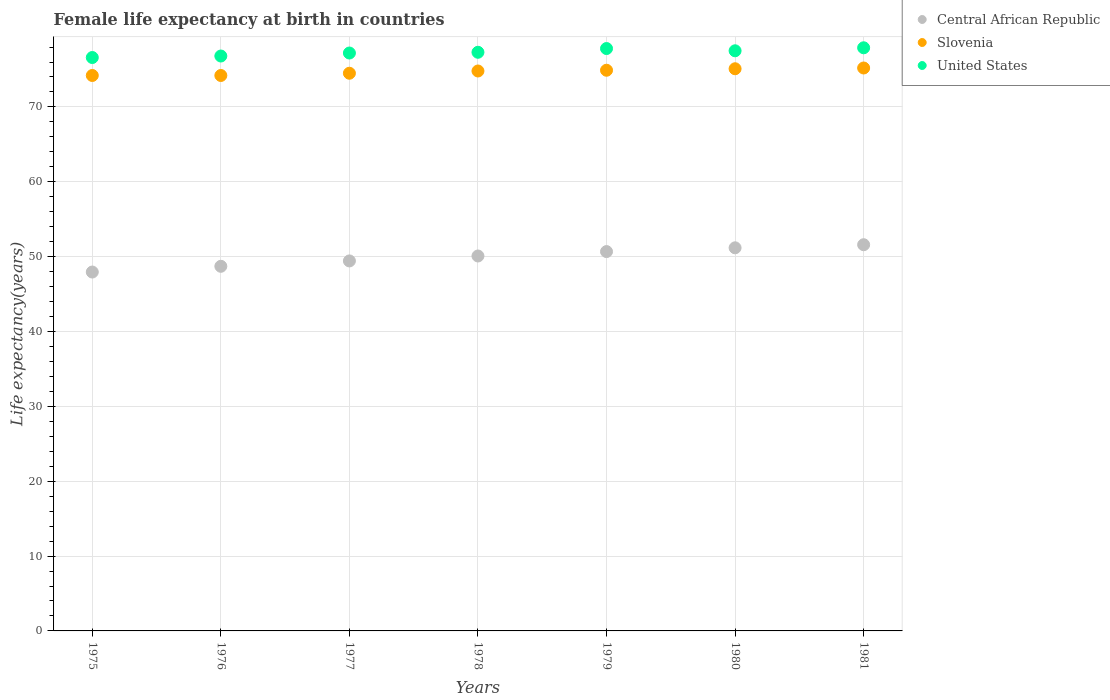What is the female life expectancy at birth in Central African Republic in 1977?
Your response must be concise. 49.43. Across all years, what is the maximum female life expectancy at birth in Central African Republic?
Provide a succinct answer. 51.59. Across all years, what is the minimum female life expectancy at birth in Central African Republic?
Your answer should be very brief. 47.94. In which year was the female life expectancy at birth in Central African Republic maximum?
Provide a short and direct response. 1981. In which year was the female life expectancy at birth in Central African Republic minimum?
Offer a very short reply. 1975. What is the total female life expectancy at birth in Slovenia in the graph?
Give a very brief answer. 522.9. What is the difference between the female life expectancy at birth in Slovenia in 1975 and that in 1976?
Ensure brevity in your answer.  0. What is the difference between the female life expectancy at birth in United States in 1981 and the female life expectancy at birth in Central African Republic in 1976?
Provide a short and direct response. 29.19. What is the average female life expectancy at birth in Slovenia per year?
Keep it short and to the point. 74.7. In the year 1977, what is the difference between the female life expectancy at birth in Slovenia and female life expectancy at birth in Central African Republic?
Give a very brief answer. 25.07. What is the ratio of the female life expectancy at birth in Slovenia in 1976 to that in 1981?
Make the answer very short. 0.99. Is the female life expectancy at birth in United States in 1976 less than that in 1980?
Keep it short and to the point. Yes. What is the difference between the highest and the second highest female life expectancy at birth in Central African Republic?
Provide a short and direct response. 0.41. What is the difference between the highest and the lowest female life expectancy at birth in United States?
Offer a very short reply. 1.3. Is the sum of the female life expectancy at birth in Slovenia in 1977 and 1979 greater than the maximum female life expectancy at birth in Central African Republic across all years?
Give a very brief answer. Yes. Does the female life expectancy at birth in United States monotonically increase over the years?
Offer a terse response. No. Is the female life expectancy at birth in United States strictly less than the female life expectancy at birth in Slovenia over the years?
Offer a very short reply. No. How many dotlines are there?
Your response must be concise. 3. How many years are there in the graph?
Provide a succinct answer. 7. Are the values on the major ticks of Y-axis written in scientific E-notation?
Give a very brief answer. No. Does the graph contain grids?
Give a very brief answer. Yes. Where does the legend appear in the graph?
Offer a very short reply. Top right. What is the title of the graph?
Offer a terse response. Female life expectancy at birth in countries. What is the label or title of the X-axis?
Ensure brevity in your answer.  Years. What is the label or title of the Y-axis?
Keep it short and to the point. Life expectancy(years). What is the Life expectancy(years) in Central African Republic in 1975?
Offer a terse response. 47.94. What is the Life expectancy(years) in Slovenia in 1975?
Provide a short and direct response. 74.2. What is the Life expectancy(years) in United States in 1975?
Your answer should be very brief. 76.6. What is the Life expectancy(years) in Central African Republic in 1976?
Your response must be concise. 48.71. What is the Life expectancy(years) in Slovenia in 1976?
Keep it short and to the point. 74.2. What is the Life expectancy(years) in United States in 1976?
Offer a terse response. 76.8. What is the Life expectancy(years) of Central African Republic in 1977?
Make the answer very short. 49.43. What is the Life expectancy(years) of Slovenia in 1977?
Your answer should be very brief. 74.5. What is the Life expectancy(years) of United States in 1977?
Keep it short and to the point. 77.2. What is the Life expectancy(years) of Central African Republic in 1978?
Offer a very short reply. 50.09. What is the Life expectancy(years) in Slovenia in 1978?
Your response must be concise. 74.8. What is the Life expectancy(years) in United States in 1978?
Offer a very short reply. 77.3. What is the Life expectancy(years) of Central African Republic in 1979?
Offer a terse response. 50.67. What is the Life expectancy(years) in Slovenia in 1979?
Offer a terse response. 74.9. What is the Life expectancy(years) in United States in 1979?
Give a very brief answer. 77.8. What is the Life expectancy(years) of Central African Republic in 1980?
Keep it short and to the point. 51.18. What is the Life expectancy(years) of Slovenia in 1980?
Keep it short and to the point. 75.1. What is the Life expectancy(years) of United States in 1980?
Ensure brevity in your answer.  77.5. What is the Life expectancy(years) in Central African Republic in 1981?
Give a very brief answer. 51.59. What is the Life expectancy(years) of Slovenia in 1981?
Offer a terse response. 75.2. What is the Life expectancy(years) of United States in 1981?
Your answer should be compact. 77.9. Across all years, what is the maximum Life expectancy(years) in Central African Republic?
Give a very brief answer. 51.59. Across all years, what is the maximum Life expectancy(years) of Slovenia?
Offer a terse response. 75.2. Across all years, what is the maximum Life expectancy(years) of United States?
Ensure brevity in your answer.  77.9. Across all years, what is the minimum Life expectancy(years) in Central African Republic?
Your answer should be compact. 47.94. Across all years, what is the minimum Life expectancy(years) of Slovenia?
Offer a very short reply. 74.2. Across all years, what is the minimum Life expectancy(years) in United States?
Provide a succinct answer. 76.6. What is the total Life expectancy(years) of Central African Republic in the graph?
Your answer should be compact. 349.61. What is the total Life expectancy(years) in Slovenia in the graph?
Your response must be concise. 522.9. What is the total Life expectancy(years) in United States in the graph?
Provide a short and direct response. 541.1. What is the difference between the Life expectancy(years) of Central African Republic in 1975 and that in 1976?
Your answer should be compact. -0.77. What is the difference between the Life expectancy(years) in United States in 1975 and that in 1976?
Keep it short and to the point. -0.2. What is the difference between the Life expectancy(years) in Central African Republic in 1975 and that in 1977?
Give a very brief answer. -1.48. What is the difference between the Life expectancy(years) in Slovenia in 1975 and that in 1977?
Provide a succinct answer. -0.3. What is the difference between the Life expectancy(years) in Central African Republic in 1975 and that in 1978?
Offer a terse response. -2.14. What is the difference between the Life expectancy(years) in Central African Republic in 1975 and that in 1979?
Your answer should be very brief. -2.73. What is the difference between the Life expectancy(years) in Slovenia in 1975 and that in 1979?
Provide a short and direct response. -0.7. What is the difference between the Life expectancy(years) of Central African Republic in 1975 and that in 1980?
Your answer should be compact. -3.24. What is the difference between the Life expectancy(years) of United States in 1975 and that in 1980?
Give a very brief answer. -0.9. What is the difference between the Life expectancy(years) of Central African Republic in 1975 and that in 1981?
Offer a very short reply. -3.65. What is the difference between the Life expectancy(years) in Slovenia in 1975 and that in 1981?
Your answer should be compact. -1. What is the difference between the Life expectancy(years) of Central African Republic in 1976 and that in 1977?
Your answer should be very brief. -0.72. What is the difference between the Life expectancy(years) of Central African Republic in 1976 and that in 1978?
Ensure brevity in your answer.  -1.38. What is the difference between the Life expectancy(years) in Slovenia in 1976 and that in 1978?
Ensure brevity in your answer.  -0.6. What is the difference between the Life expectancy(years) of Central African Republic in 1976 and that in 1979?
Your answer should be compact. -1.97. What is the difference between the Life expectancy(years) of Slovenia in 1976 and that in 1979?
Provide a short and direct response. -0.7. What is the difference between the Life expectancy(years) in Central African Republic in 1976 and that in 1980?
Your answer should be very brief. -2.47. What is the difference between the Life expectancy(years) in United States in 1976 and that in 1980?
Keep it short and to the point. -0.7. What is the difference between the Life expectancy(years) of Central African Republic in 1976 and that in 1981?
Your answer should be very brief. -2.88. What is the difference between the Life expectancy(years) in Slovenia in 1976 and that in 1981?
Make the answer very short. -1. What is the difference between the Life expectancy(years) of Central African Republic in 1977 and that in 1978?
Your answer should be very brief. -0.66. What is the difference between the Life expectancy(years) of Slovenia in 1977 and that in 1978?
Give a very brief answer. -0.3. What is the difference between the Life expectancy(years) of United States in 1977 and that in 1978?
Offer a very short reply. -0.1. What is the difference between the Life expectancy(years) of Central African Republic in 1977 and that in 1979?
Offer a terse response. -1.25. What is the difference between the Life expectancy(years) in Central African Republic in 1977 and that in 1980?
Offer a very short reply. -1.75. What is the difference between the Life expectancy(years) in Slovenia in 1977 and that in 1980?
Make the answer very short. -0.6. What is the difference between the Life expectancy(years) of Central African Republic in 1977 and that in 1981?
Ensure brevity in your answer.  -2.17. What is the difference between the Life expectancy(years) of Central African Republic in 1978 and that in 1979?
Provide a succinct answer. -0.59. What is the difference between the Life expectancy(years) of Slovenia in 1978 and that in 1979?
Offer a very short reply. -0.1. What is the difference between the Life expectancy(years) of Central African Republic in 1978 and that in 1980?
Keep it short and to the point. -1.09. What is the difference between the Life expectancy(years) in Central African Republic in 1978 and that in 1981?
Your response must be concise. -1.5. What is the difference between the Life expectancy(years) of Central African Republic in 1979 and that in 1980?
Give a very brief answer. -0.5. What is the difference between the Life expectancy(years) of Slovenia in 1979 and that in 1980?
Your response must be concise. -0.2. What is the difference between the Life expectancy(years) of United States in 1979 and that in 1980?
Provide a short and direct response. 0.3. What is the difference between the Life expectancy(years) of Central African Republic in 1979 and that in 1981?
Keep it short and to the point. -0.92. What is the difference between the Life expectancy(years) of Central African Republic in 1980 and that in 1981?
Provide a short and direct response. -0.41. What is the difference between the Life expectancy(years) of Slovenia in 1980 and that in 1981?
Ensure brevity in your answer.  -0.1. What is the difference between the Life expectancy(years) of Central African Republic in 1975 and the Life expectancy(years) of Slovenia in 1976?
Ensure brevity in your answer.  -26.26. What is the difference between the Life expectancy(years) of Central African Republic in 1975 and the Life expectancy(years) of United States in 1976?
Offer a terse response. -28.86. What is the difference between the Life expectancy(years) of Slovenia in 1975 and the Life expectancy(years) of United States in 1976?
Offer a very short reply. -2.6. What is the difference between the Life expectancy(years) of Central African Republic in 1975 and the Life expectancy(years) of Slovenia in 1977?
Keep it short and to the point. -26.56. What is the difference between the Life expectancy(years) of Central African Republic in 1975 and the Life expectancy(years) of United States in 1977?
Your answer should be compact. -29.26. What is the difference between the Life expectancy(years) of Central African Republic in 1975 and the Life expectancy(years) of Slovenia in 1978?
Give a very brief answer. -26.86. What is the difference between the Life expectancy(years) in Central African Republic in 1975 and the Life expectancy(years) in United States in 1978?
Provide a succinct answer. -29.36. What is the difference between the Life expectancy(years) in Slovenia in 1975 and the Life expectancy(years) in United States in 1978?
Provide a succinct answer. -3.1. What is the difference between the Life expectancy(years) in Central African Republic in 1975 and the Life expectancy(years) in Slovenia in 1979?
Offer a terse response. -26.96. What is the difference between the Life expectancy(years) of Central African Republic in 1975 and the Life expectancy(years) of United States in 1979?
Make the answer very short. -29.86. What is the difference between the Life expectancy(years) of Central African Republic in 1975 and the Life expectancy(years) of Slovenia in 1980?
Ensure brevity in your answer.  -27.16. What is the difference between the Life expectancy(years) in Central African Republic in 1975 and the Life expectancy(years) in United States in 1980?
Your answer should be compact. -29.56. What is the difference between the Life expectancy(years) in Central African Republic in 1975 and the Life expectancy(years) in Slovenia in 1981?
Make the answer very short. -27.26. What is the difference between the Life expectancy(years) in Central African Republic in 1975 and the Life expectancy(years) in United States in 1981?
Give a very brief answer. -29.96. What is the difference between the Life expectancy(years) in Slovenia in 1975 and the Life expectancy(years) in United States in 1981?
Offer a very short reply. -3.7. What is the difference between the Life expectancy(years) of Central African Republic in 1976 and the Life expectancy(years) of Slovenia in 1977?
Offer a terse response. -25.79. What is the difference between the Life expectancy(years) in Central African Republic in 1976 and the Life expectancy(years) in United States in 1977?
Provide a succinct answer. -28.49. What is the difference between the Life expectancy(years) in Slovenia in 1976 and the Life expectancy(years) in United States in 1977?
Give a very brief answer. -3. What is the difference between the Life expectancy(years) of Central African Republic in 1976 and the Life expectancy(years) of Slovenia in 1978?
Provide a short and direct response. -26.09. What is the difference between the Life expectancy(years) of Central African Republic in 1976 and the Life expectancy(years) of United States in 1978?
Ensure brevity in your answer.  -28.59. What is the difference between the Life expectancy(years) of Central African Republic in 1976 and the Life expectancy(years) of Slovenia in 1979?
Keep it short and to the point. -26.19. What is the difference between the Life expectancy(years) in Central African Republic in 1976 and the Life expectancy(years) in United States in 1979?
Give a very brief answer. -29.09. What is the difference between the Life expectancy(years) in Slovenia in 1976 and the Life expectancy(years) in United States in 1979?
Provide a short and direct response. -3.6. What is the difference between the Life expectancy(years) of Central African Republic in 1976 and the Life expectancy(years) of Slovenia in 1980?
Keep it short and to the point. -26.39. What is the difference between the Life expectancy(years) of Central African Republic in 1976 and the Life expectancy(years) of United States in 1980?
Your answer should be very brief. -28.79. What is the difference between the Life expectancy(years) of Slovenia in 1976 and the Life expectancy(years) of United States in 1980?
Provide a short and direct response. -3.3. What is the difference between the Life expectancy(years) of Central African Republic in 1976 and the Life expectancy(years) of Slovenia in 1981?
Your response must be concise. -26.49. What is the difference between the Life expectancy(years) of Central African Republic in 1976 and the Life expectancy(years) of United States in 1981?
Provide a short and direct response. -29.19. What is the difference between the Life expectancy(years) of Slovenia in 1976 and the Life expectancy(years) of United States in 1981?
Provide a succinct answer. -3.7. What is the difference between the Life expectancy(years) in Central African Republic in 1977 and the Life expectancy(years) in Slovenia in 1978?
Offer a very short reply. -25.37. What is the difference between the Life expectancy(years) in Central African Republic in 1977 and the Life expectancy(years) in United States in 1978?
Provide a short and direct response. -27.87. What is the difference between the Life expectancy(years) of Central African Republic in 1977 and the Life expectancy(years) of Slovenia in 1979?
Make the answer very short. -25.47. What is the difference between the Life expectancy(years) in Central African Republic in 1977 and the Life expectancy(years) in United States in 1979?
Offer a very short reply. -28.37. What is the difference between the Life expectancy(years) in Central African Republic in 1977 and the Life expectancy(years) in Slovenia in 1980?
Your response must be concise. -25.67. What is the difference between the Life expectancy(years) of Central African Republic in 1977 and the Life expectancy(years) of United States in 1980?
Your answer should be very brief. -28.07. What is the difference between the Life expectancy(years) of Central African Republic in 1977 and the Life expectancy(years) of Slovenia in 1981?
Make the answer very short. -25.77. What is the difference between the Life expectancy(years) in Central African Republic in 1977 and the Life expectancy(years) in United States in 1981?
Keep it short and to the point. -28.47. What is the difference between the Life expectancy(years) of Slovenia in 1977 and the Life expectancy(years) of United States in 1981?
Provide a short and direct response. -3.4. What is the difference between the Life expectancy(years) of Central African Republic in 1978 and the Life expectancy(years) of Slovenia in 1979?
Offer a terse response. -24.81. What is the difference between the Life expectancy(years) in Central African Republic in 1978 and the Life expectancy(years) in United States in 1979?
Provide a short and direct response. -27.71. What is the difference between the Life expectancy(years) of Central African Republic in 1978 and the Life expectancy(years) of Slovenia in 1980?
Your answer should be compact. -25.01. What is the difference between the Life expectancy(years) in Central African Republic in 1978 and the Life expectancy(years) in United States in 1980?
Provide a short and direct response. -27.41. What is the difference between the Life expectancy(years) of Central African Republic in 1978 and the Life expectancy(years) of Slovenia in 1981?
Make the answer very short. -25.11. What is the difference between the Life expectancy(years) of Central African Republic in 1978 and the Life expectancy(years) of United States in 1981?
Provide a succinct answer. -27.81. What is the difference between the Life expectancy(years) of Central African Republic in 1979 and the Life expectancy(years) of Slovenia in 1980?
Your response must be concise. -24.43. What is the difference between the Life expectancy(years) of Central African Republic in 1979 and the Life expectancy(years) of United States in 1980?
Give a very brief answer. -26.82. What is the difference between the Life expectancy(years) in Slovenia in 1979 and the Life expectancy(years) in United States in 1980?
Provide a succinct answer. -2.6. What is the difference between the Life expectancy(years) in Central African Republic in 1979 and the Life expectancy(years) in Slovenia in 1981?
Offer a very short reply. -24.52. What is the difference between the Life expectancy(years) in Central African Republic in 1979 and the Life expectancy(years) in United States in 1981?
Your answer should be compact. -27.23. What is the difference between the Life expectancy(years) in Slovenia in 1979 and the Life expectancy(years) in United States in 1981?
Provide a short and direct response. -3. What is the difference between the Life expectancy(years) of Central African Republic in 1980 and the Life expectancy(years) of Slovenia in 1981?
Make the answer very short. -24.02. What is the difference between the Life expectancy(years) in Central African Republic in 1980 and the Life expectancy(years) in United States in 1981?
Ensure brevity in your answer.  -26.72. What is the difference between the Life expectancy(years) of Slovenia in 1980 and the Life expectancy(years) of United States in 1981?
Your response must be concise. -2.8. What is the average Life expectancy(years) in Central African Republic per year?
Ensure brevity in your answer.  49.94. What is the average Life expectancy(years) of Slovenia per year?
Ensure brevity in your answer.  74.7. What is the average Life expectancy(years) of United States per year?
Give a very brief answer. 77.3. In the year 1975, what is the difference between the Life expectancy(years) in Central African Republic and Life expectancy(years) in Slovenia?
Provide a short and direct response. -26.26. In the year 1975, what is the difference between the Life expectancy(years) in Central African Republic and Life expectancy(years) in United States?
Provide a short and direct response. -28.66. In the year 1976, what is the difference between the Life expectancy(years) in Central African Republic and Life expectancy(years) in Slovenia?
Keep it short and to the point. -25.49. In the year 1976, what is the difference between the Life expectancy(years) of Central African Republic and Life expectancy(years) of United States?
Your answer should be very brief. -28.09. In the year 1977, what is the difference between the Life expectancy(years) of Central African Republic and Life expectancy(years) of Slovenia?
Provide a short and direct response. -25.07. In the year 1977, what is the difference between the Life expectancy(years) in Central African Republic and Life expectancy(years) in United States?
Provide a short and direct response. -27.77. In the year 1977, what is the difference between the Life expectancy(years) of Slovenia and Life expectancy(years) of United States?
Ensure brevity in your answer.  -2.7. In the year 1978, what is the difference between the Life expectancy(years) of Central African Republic and Life expectancy(years) of Slovenia?
Keep it short and to the point. -24.71. In the year 1978, what is the difference between the Life expectancy(years) in Central African Republic and Life expectancy(years) in United States?
Make the answer very short. -27.21. In the year 1979, what is the difference between the Life expectancy(years) in Central African Republic and Life expectancy(years) in Slovenia?
Your response must be concise. -24.23. In the year 1979, what is the difference between the Life expectancy(years) in Central African Republic and Life expectancy(years) in United States?
Give a very brief answer. -27.12. In the year 1980, what is the difference between the Life expectancy(years) of Central African Republic and Life expectancy(years) of Slovenia?
Give a very brief answer. -23.92. In the year 1980, what is the difference between the Life expectancy(years) in Central African Republic and Life expectancy(years) in United States?
Your response must be concise. -26.32. In the year 1980, what is the difference between the Life expectancy(years) of Slovenia and Life expectancy(years) of United States?
Ensure brevity in your answer.  -2.4. In the year 1981, what is the difference between the Life expectancy(years) of Central African Republic and Life expectancy(years) of Slovenia?
Your answer should be compact. -23.61. In the year 1981, what is the difference between the Life expectancy(years) of Central African Republic and Life expectancy(years) of United States?
Provide a succinct answer. -26.31. In the year 1981, what is the difference between the Life expectancy(years) in Slovenia and Life expectancy(years) in United States?
Keep it short and to the point. -2.7. What is the ratio of the Life expectancy(years) in Central African Republic in 1975 to that in 1976?
Ensure brevity in your answer.  0.98. What is the ratio of the Life expectancy(years) of Central African Republic in 1975 to that in 1977?
Make the answer very short. 0.97. What is the ratio of the Life expectancy(years) of United States in 1975 to that in 1977?
Ensure brevity in your answer.  0.99. What is the ratio of the Life expectancy(years) in Central African Republic in 1975 to that in 1978?
Provide a succinct answer. 0.96. What is the ratio of the Life expectancy(years) in United States in 1975 to that in 1978?
Offer a terse response. 0.99. What is the ratio of the Life expectancy(years) in Central African Republic in 1975 to that in 1979?
Your response must be concise. 0.95. What is the ratio of the Life expectancy(years) of Slovenia in 1975 to that in 1979?
Give a very brief answer. 0.99. What is the ratio of the Life expectancy(years) in United States in 1975 to that in 1979?
Your answer should be very brief. 0.98. What is the ratio of the Life expectancy(years) in Central African Republic in 1975 to that in 1980?
Give a very brief answer. 0.94. What is the ratio of the Life expectancy(years) of United States in 1975 to that in 1980?
Your answer should be compact. 0.99. What is the ratio of the Life expectancy(years) of Central African Republic in 1975 to that in 1981?
Make the answer very short. 0.93. What is the ratio of the Life expectancy(years) of Slovenia in 1975 to that in 1981?
Provide a succinct answer. 0.99. What is the ratio of the Life expectancy(years) of United States in 1975 to that in 1981?
Your answer should be compact. 0.98. What is the ratio of the Life expectancy(years) in Central African Republic in 1976 to that in 1977?
Keep it short and to the point. 0.99. What is the ratio of the Life expectancy(years) in United States in 1976 to that in 1977?
Give a very brief answer. 0.99. What is the ratio of the Life expectancy(years) in Central African Republic in 1976 to that in 1978?
Make the answer very short. 0.97. What is the ratio of the Life expectancy(years) in Central African Republic in 1976 to that in 1979?
Your answer should be very brief. 0.96. What is the ratio of the Life expectancy(years) in United States in 1976 to that in 1979?
Keep it short and to the point. 0.99. What is the ratio of the Life expectancy(years) in Central African Republic in 1976 to that in 1980?
Your answer should be very brief. 0.95. What is the ratio of the Life expectancy(years) in United States in 1976 to that in 1980?
Make the answer very short. 0.99. What is the ratio of the Life expectancy(years) of Central African Republic in 1976 to that in 1981?
Offer a terse response. 0.94. What is the ratio of the Life expectancy(years) of Slovenia in 1976 to that in 1981?
Your answer should be very brief. 0.99. What is the ratio of the Life expectancy(years) of United States in 1976 to that in 1981?
Make the answer very short. 0.99. What is the ratio of the Life expectancy(years) of Slovenia in 1977 to that in 1978?
Keep it short and to the point. 1. What is the ratio of the Life expectancy(years) in Central African Republic in 1977 to that in 1979?
Give a very brief answer. 0.98. What is the ratio of the Life expectancy(years) of Central African Republic in 1977 to that in 1980?
Offer a terse response. 0.97. What is the ratio of the Life expectancy(years) in United States in 1977 to that in 1980?
Your answer should be compact. 1. What is the ratio of the Life expectancy(years) of Central African Republic in 1977 to that in 1981?
Ensure brevity in your answer.  0.96. What is the ratio of the Life expectancy(years) in United States in 1977 to that in 1981?
Keep it short and to the point. 0.99. What is the ratio of the Life expectancy(years) in Central African Republic in 1978 to that in 1979?
Keep it short and to the point. 0.99. What is the ratio of the Life expectancy(years) of Slovenia in 1978 to that in 1979?
Offer a terse response. 1. What is the ratio of the Life expectancy(years) in United States in 1978 to that in 1979?
Provide a succinct answer. 0.99. What is the ratio of the Life expectancy(years) in Central African Republic in 1978 to that in 1980?
Ensure brevity in your answer.  0.98. What is the ratio of the Life expectancy(years) of Slovenia in 1978 to that in 1980?
Keep it short and to the point. 1. What is the ratio of the Life expectancy(years) in United States in 1978 to that in 1980?
Offer a terse response. 1. What is the ratio of the Life expectancy(years) of Central African Republic in 1978 to that in 1981?
Offer a very short reply. 0.97. What is the ratio of the Life expectancy(years) of Slovenia in 1978 to that in 1981?
Provide a succinct answer. 0.99. What is the ratio of the Life expectancy(years) in United States in 1978 to that in 1981?
Your answer should be very brief. 0.99. What is the ratio of the Life expectancy(years) of Central African Republic in 1979 to that in 1980?
Offer a very short reply. 0.99. What is the ratio of the Life expectancy(years) in United States in 1979 to that in 1980?
Give a very brief answer. 1. What is the ratio of the Life expectancy(years) of Central African Republic in 1979 to that in 1981?
Provide a short and direct response. 0.98. What is the ratio of the Life expectancy(years) of United States in 1979 to that in 1981?
Your response must be concise. 1. What is the ratio of the Life expectancy(years) of Central African Republic in 1980 to that in 1981?
Offer a very short reply. 0.99. What is the difference between the highest and the second highest Life expectancy(years) in Central African Republic?
Your answer should be compact. 0.41. What is the difference between the highest and the second highest Life expectancy(years) of Slovenia?
Make the answer very short. 0.1. What is the difference between the highest and the second highest Life expectancy(years) in United States?
Your answer should be compact. 0.1. What is the difference between the highest and the lowest Life expectancy(years) in Central African Republic?
Offer a very short reply. 3.65. What is the difference between the highest and the lowest Life expectancy(years) in Slovenia?
Keep it short and to the point. 1. What is the difference between the highest and the lowest Life expectancy(years) in United States?
Keep it short and to the point. 1.3. 